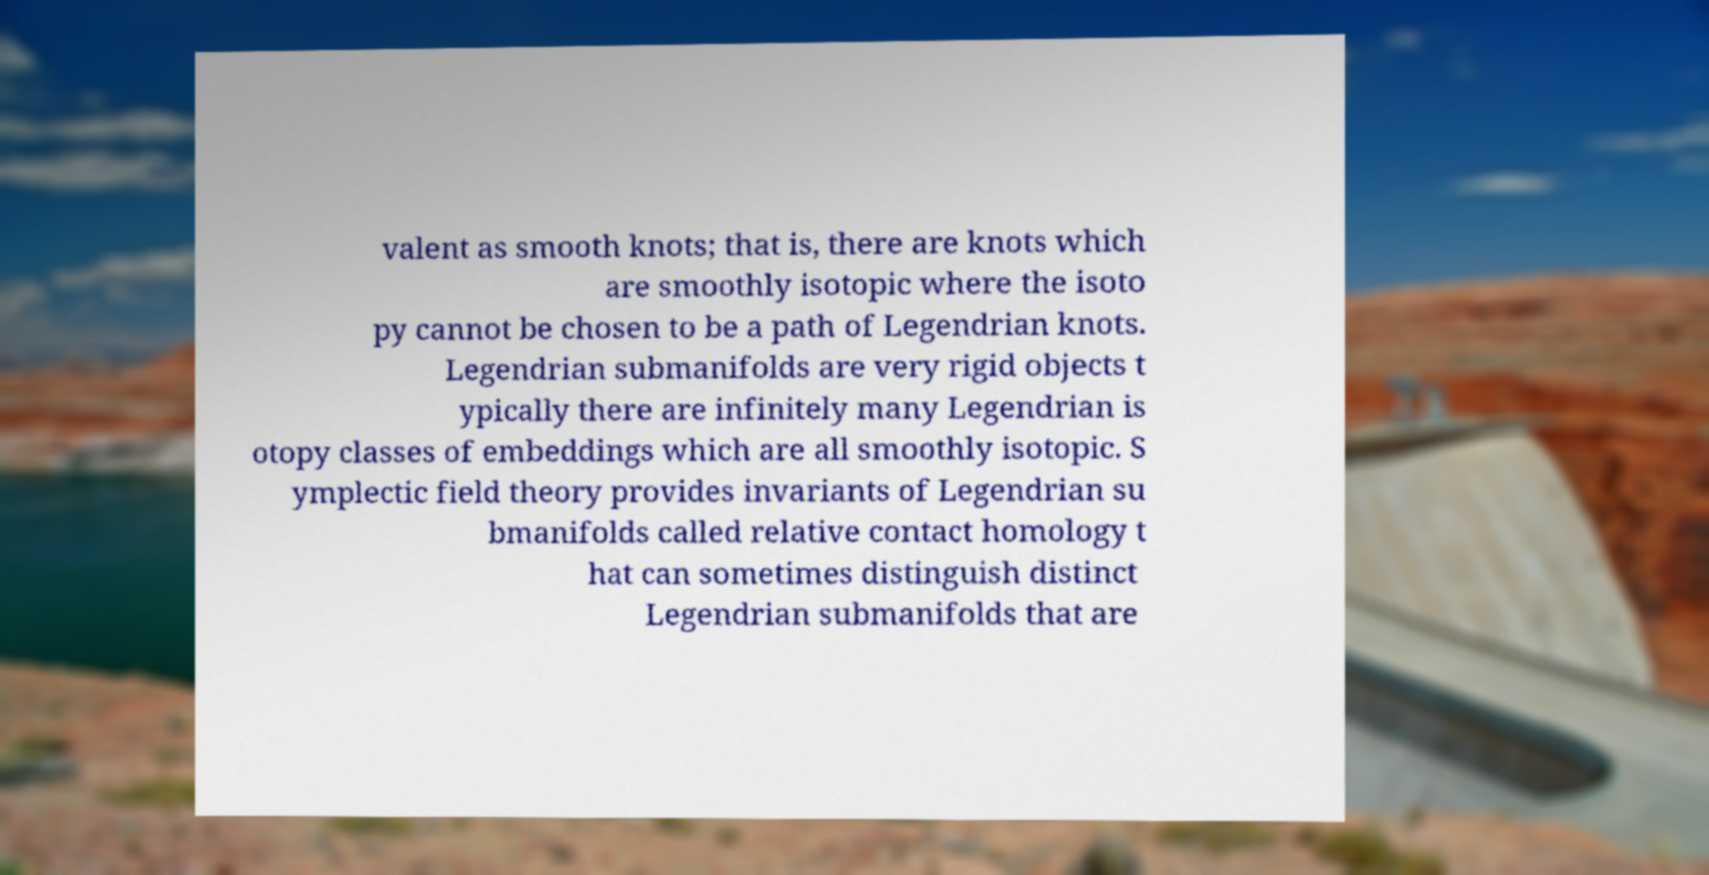Please read and relay the text visible in this image. What does it say? valent as smooth knots; that is, there are knots which are smoothly isotopic where the isoto py cannot be chosen to be a path of Legendrian knots. Legendrian submanifolds are very rigid objects t ypically there are infinitely many Legendrian is otopy classes of embeddings which are all smoothly isotopic. S ymplectic field theory provides invariants of Legendrian su bmanifolds called relative contact homology t hat can sometimes distinguish distinct Legendrian submanifolds that are 